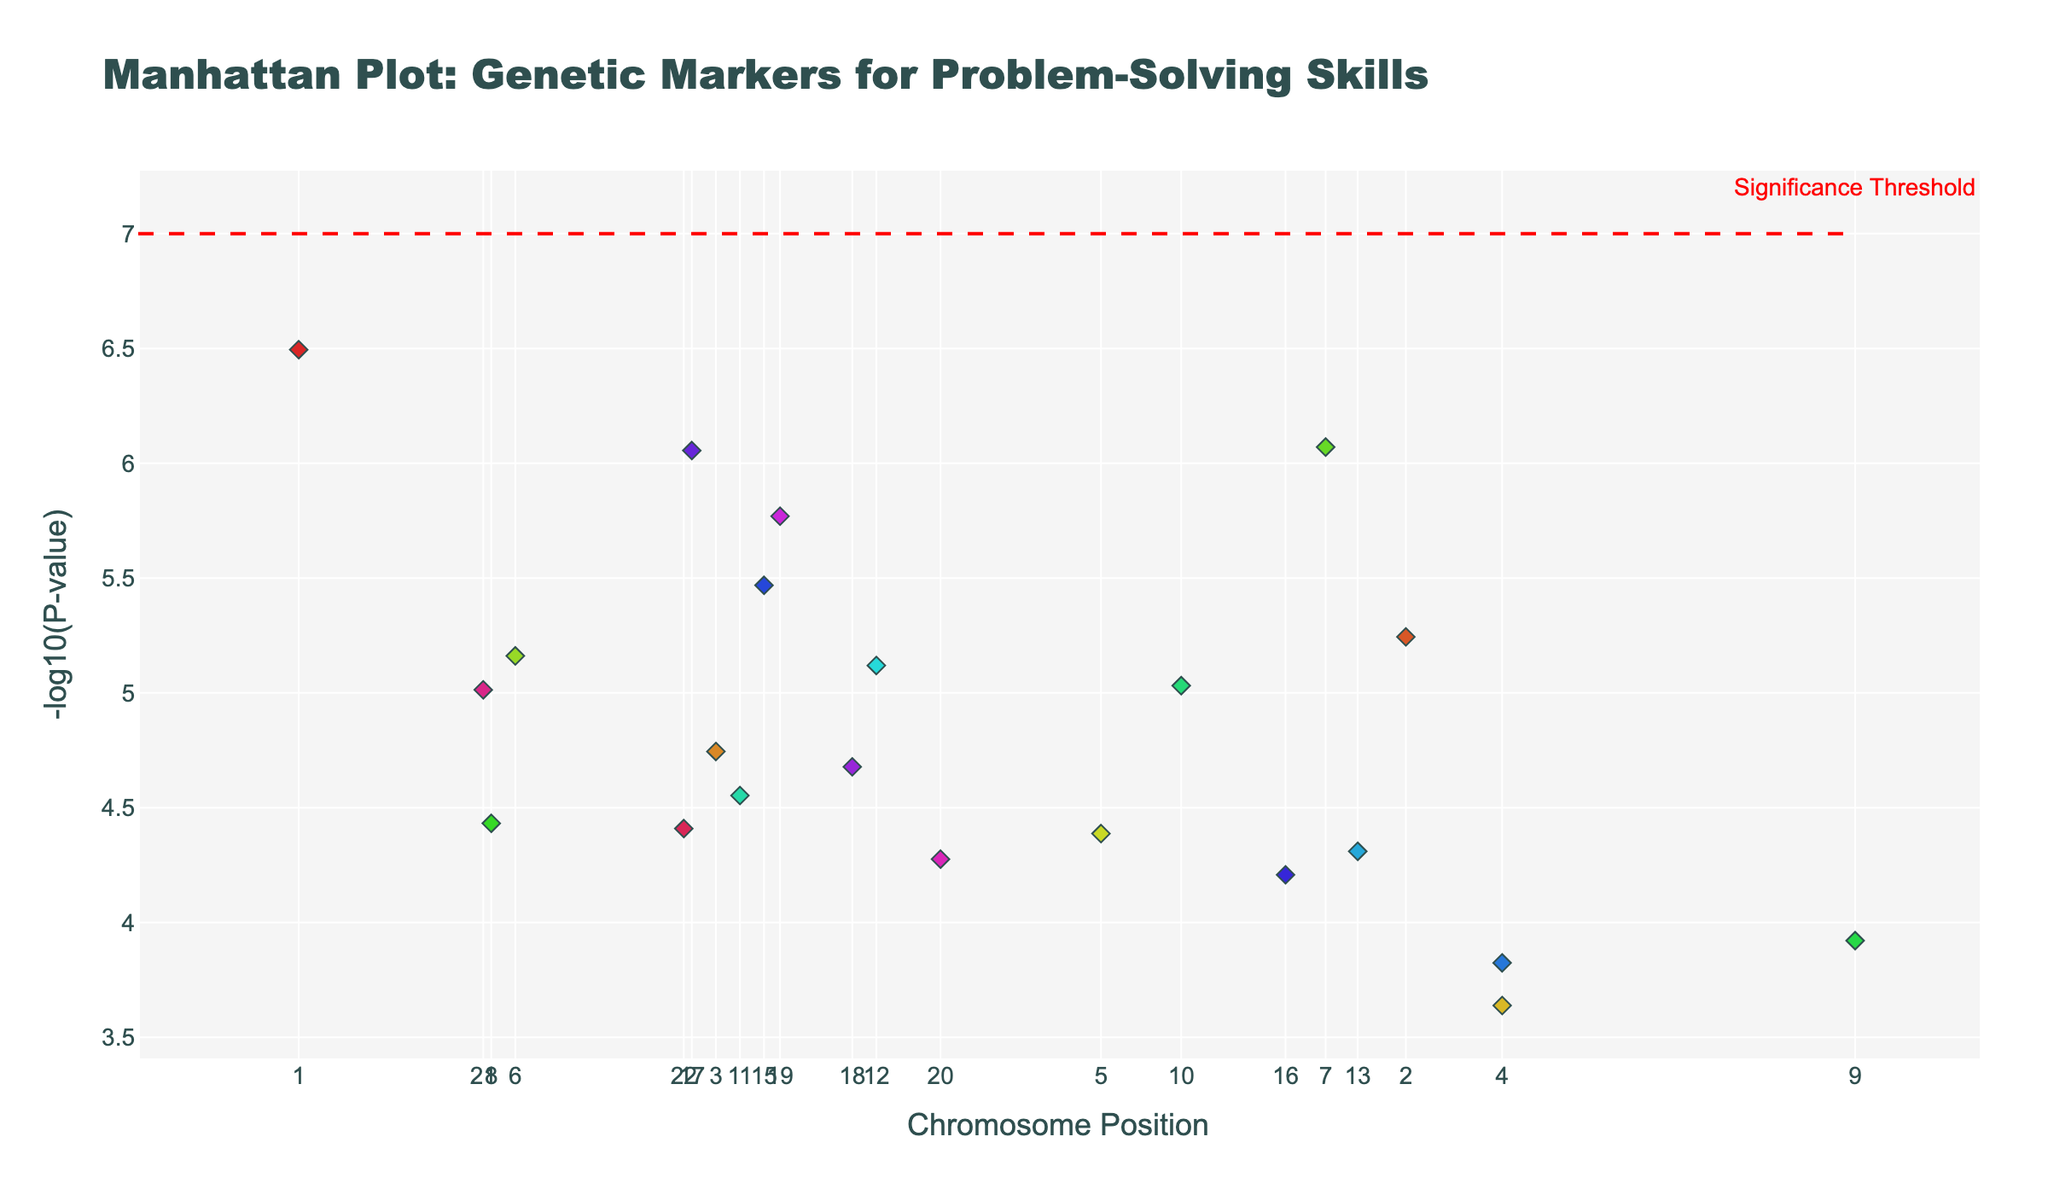How many data points are plotted for Chromosome 10? Count the number of markers associated with Chromosome 10.
Answer: 1 What is the y-axis label? Look at the y-axis title in the figure's layout.
Answer: -log10(P-value) Which chromosome has the highest data point? Compare the peak values across all chromosomes to find the highest point.
Answer: 1 What gene is associated with the SNP rs7782412? Use the hover information or reference the table to find the gene linked to this SNP.
Answer: FOXP2 What is the significance threshold line's y-value? Observe the horizontal line marked on the y-axis that indicates significance.
Answer: 7 Which gene has the lowest p-value, and on which chromosome is it located? Identify the data point with the highest -log10(P-value) and find its associated gene and chromosome.
Answer: FOXP2 on Chromosome 1 How many data points have -log10(P-value) greater than 7? Count all markers above the significance threshold line based on their y-values.
Answer: 3 Between Chromosome 7 and Chromosome 17, which one has a data point closer to the significance threshold but below it? Compare the y-values (distance from 7) of specified chromosomes for data points below the threshold.
Answer: Chromosome 17 Which chromosome has the most data points plotted? Compare the number of data points across all chromosomes.
Answer: Chromosome 4 What is the average of -log10(P-value) for data points on Chromosome 3? Sum all -log10(P-value) for Chromosome 3 and divide by the number of data points.
Answer: 4.744 